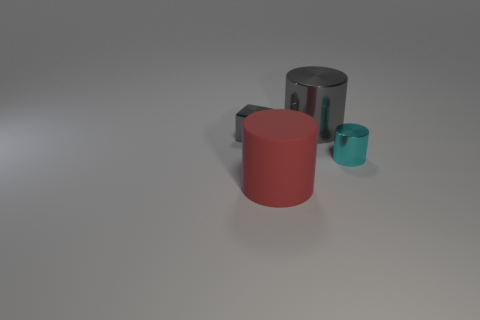Add 2 small cyan metallic cylinders. How many objects exist? 6 Subtract all blocks. How many objects are left? 3 Add 1 tiny cyan cylinders. How many tiny cyan cylinders are left? 2 Add 2 tiny things. How many tiny things exist? 4 Subtract 0 purple spheres. How many objects are left? 4 Subtract all large gray metallic objects. Subtract all gray cylinders. How many objects are left? 2 